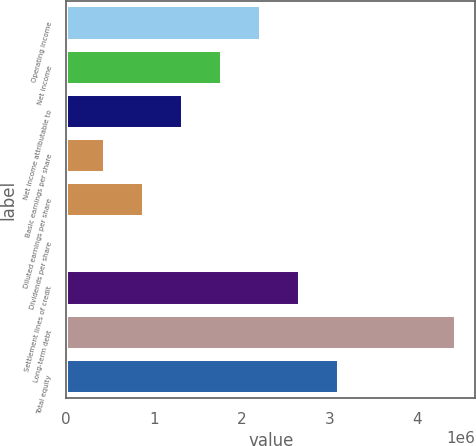Convert chart. <chart><loc_0><loc_0><loc_500><loc_500><bar_chart><fcel>Operating income<fcel>Net income<fcel>Net income attributable to<fcel>Basic earnings per share<fcel>Diluted earnings per share<fcel>Dividends per share<fcel>Settlement lines of credit<fcel>Long-term debt<fcel>Total equity<nl><fcel>2.21931e+06<fcel>1.77544e+06<fcel>1.33158e+06<fcel>443861<fcel>887722<fcel>0.02<fcel>2.66317e+06<fcel>4.43861e+06<fcel>3.10703e+06<nl></chart> 